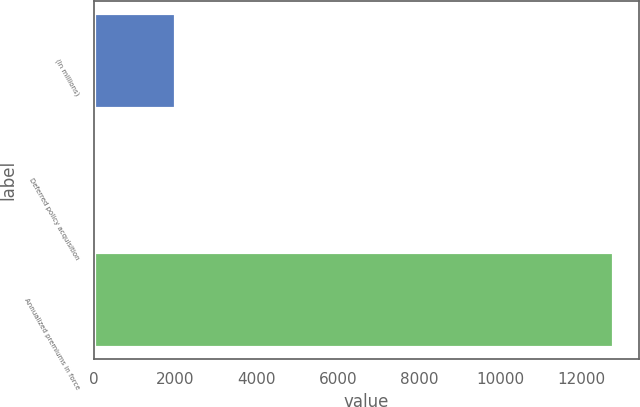Convert chart. <chart><loc_0><loc_0><loc_500><loc_500><bar_chart><fcel>(In millions)<fcel>Deferred policy acquisition<fcel>Annualized premiums in force<nl><fcel>2008<fcel>44.2<fcel>12761<nl></chart> 